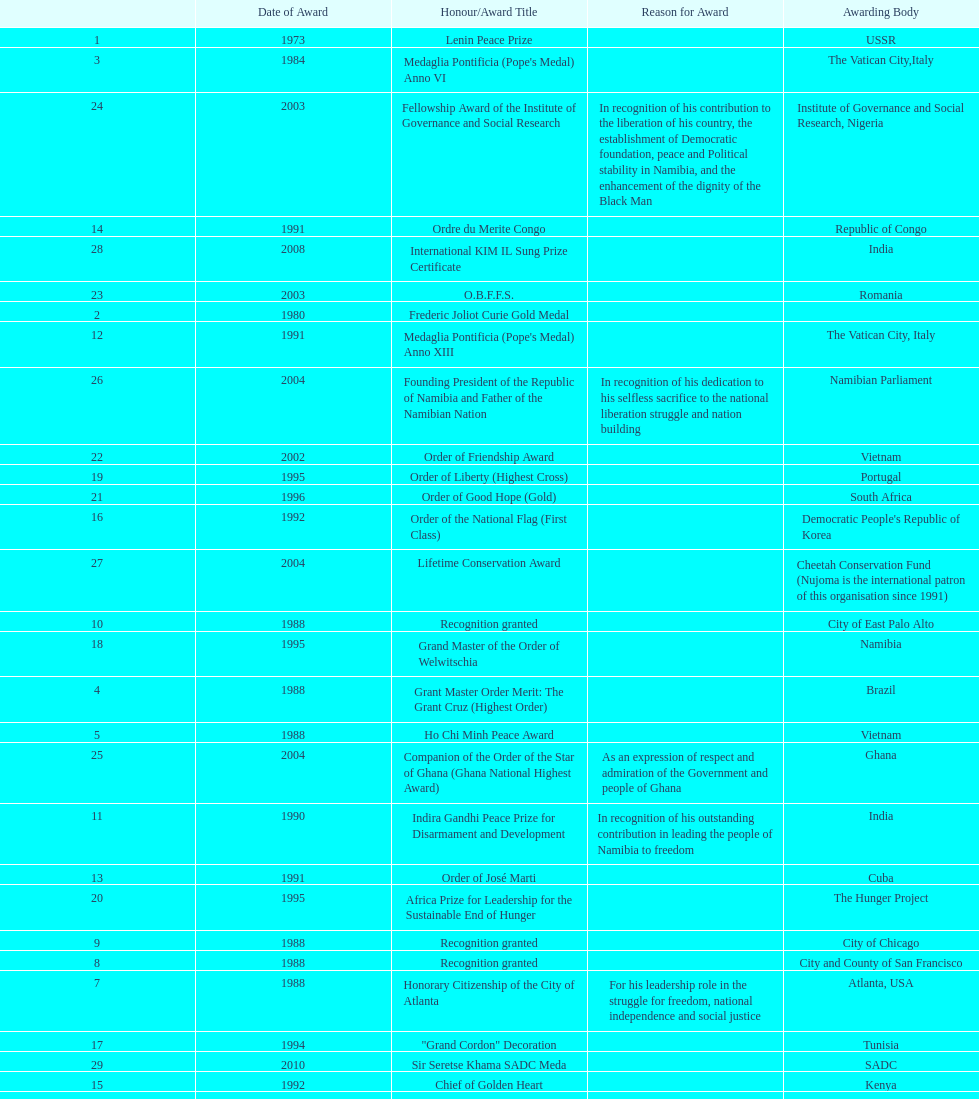The "fellowship award of the institute of governance and social research" was awarded in 2003 or 2004? 2003. 